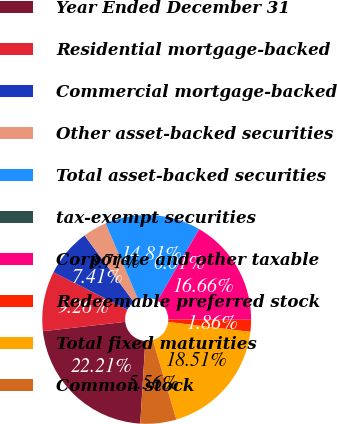Convert chart to OTSL. <chart><loc_0><loc_0><loc_500><loc_500><pie_chart><fcel>Year Ended December 31<fcel>Residential mortgage-backed<fcel>Commercial mortgage-backed<fcel>Other asset-backed securities<fcel>Total asset-backed securities<fcel>tax-exempt securities<fcel>Corporate and other taxable<fcel>Redeemable preferred stock<fcel>Total fixed maturities<fcel>Common stock<nl><fcel>22.21%<fcel>9.26%<fcel>7.41%<fcel>3.71%<fcel>14.81%<fcel>0.01%<fcel>16.66%<fcel>1.86%<fcel>18.51%<fcel>5.56%<nl></chart> 